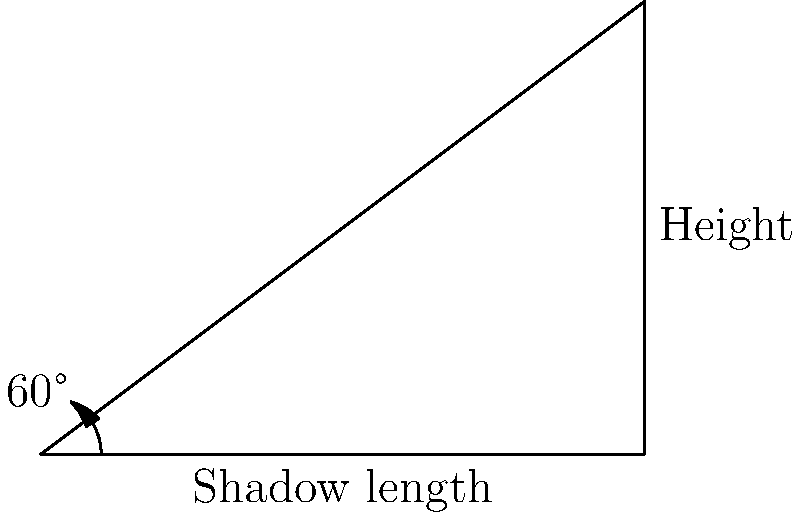Yo, check it out! We're at the Def Jam Recordings HQ, and we wanna measure this dope skyscraper's height using its shadow. The sun's shining at a 60° angle, creating a shadow that's as long as 8 platinum records laid end-to-end. Each record is 1 foot wide. How tall is this hip-hop empire's tower? Drop the answer in feet, and keep it real! Alright, let's break this down like a sick beat:

1) First, we gotta recognize this is a right triangle problem. The skyscraper, its shadow, and the sun's rays form a right triangle.

2) We know two things:
   - The angle of elevation (sun's angle) is 60°
   - The length of the shadow is 8 feet

3) In this right triangle:
   - The shadow length is the adjacent side to our angle
   - The skyscraper height is the opposite side
   - We're looking for the opposite when we know the adjacent and the angle

4) This screams SOH-CAH-TOA! We need the tangent function:

   $\tan(\theta) = \frac{\text{opposite}}{\text{adjacent}}$

5) Plugging in what we know:

   $\tan(60°) = \frac{\text{height}}{8}$

6) We know that $\tan(60°) = \sqrt{3}$, so:

   $\sqrt{3} = \frac{\text{height}}{8}$

7) Solve for height:

   $\text{height} = 8\sqrt{3}$

8) To get a decimal approximation:

   $\text{height} \approx 8 * 1.732 \approx 13.856$ feet

9) Rounding to the nearest foot:

   $\text{height} \approx 14$ feet

That's how tall this hip-hop high-rise stands!
Answer: 14 feet 